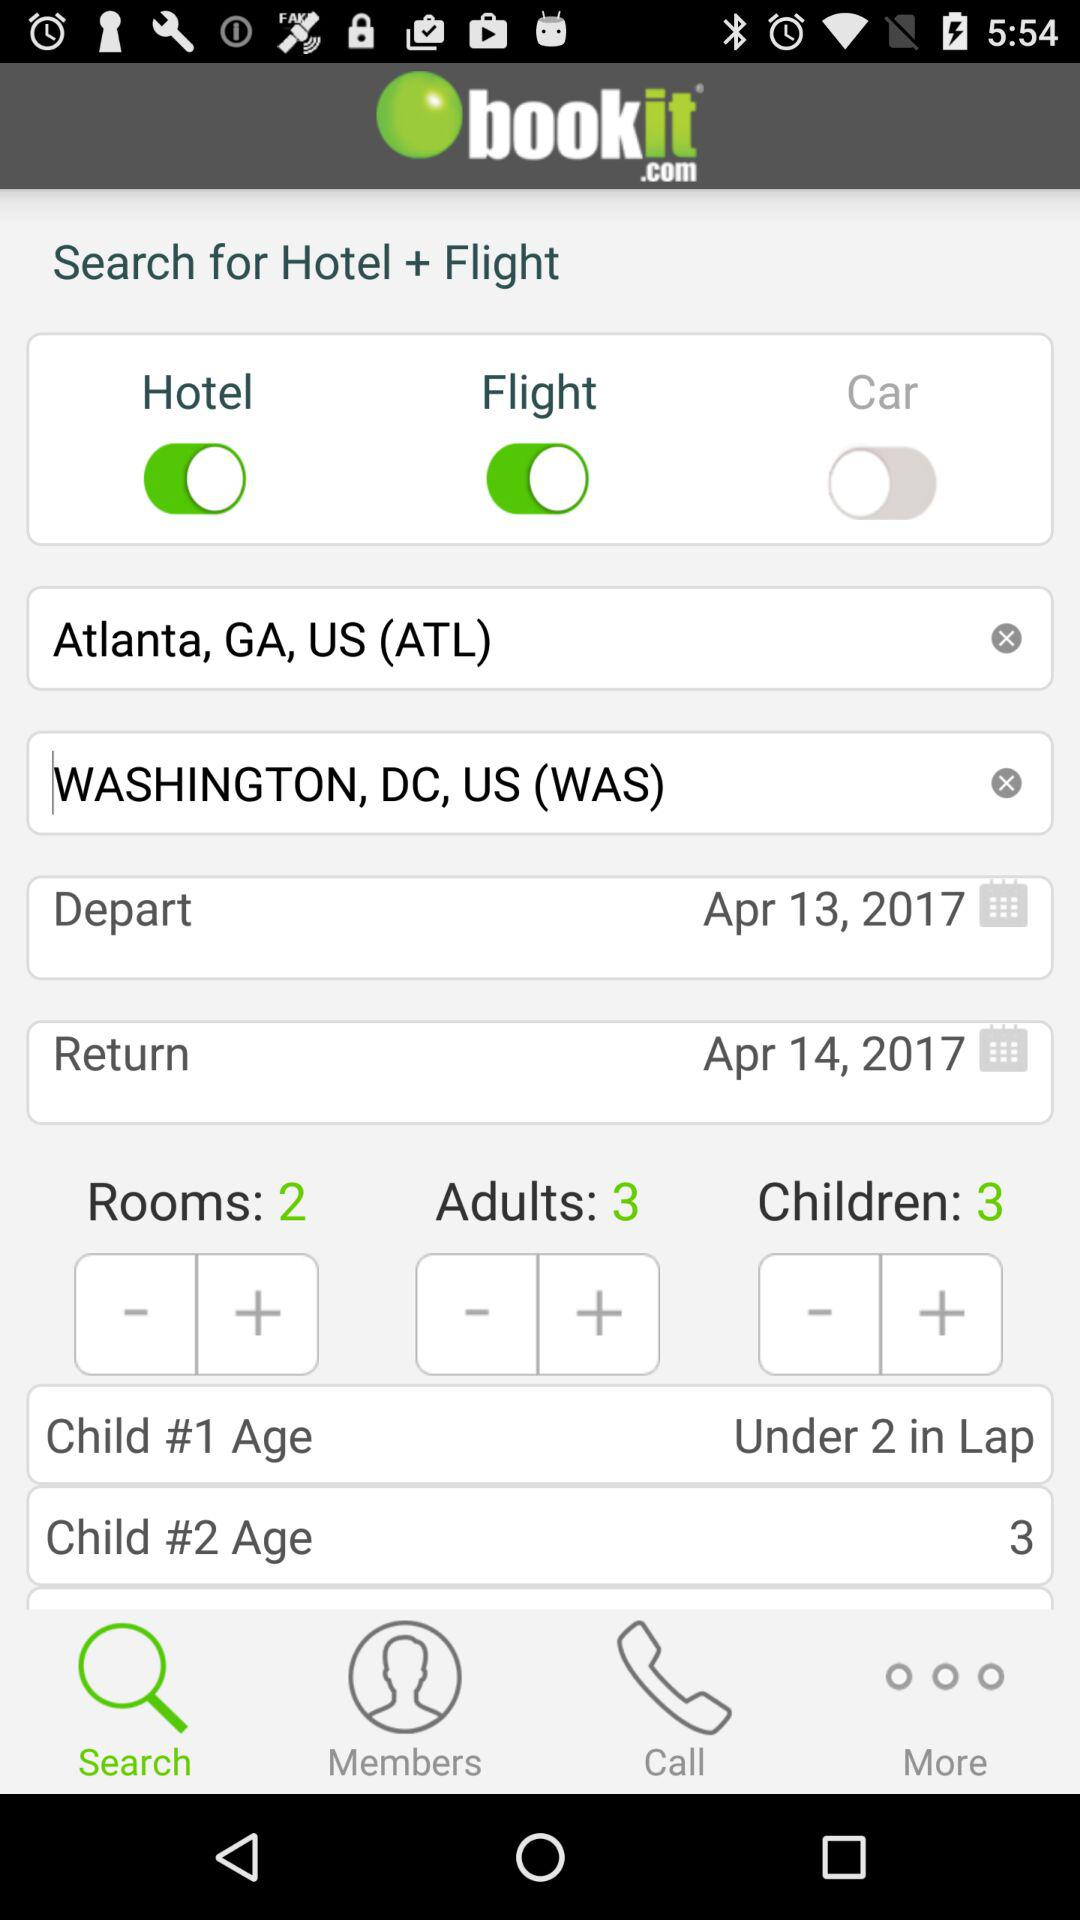What is the application name? The application name is "bookit.com". 